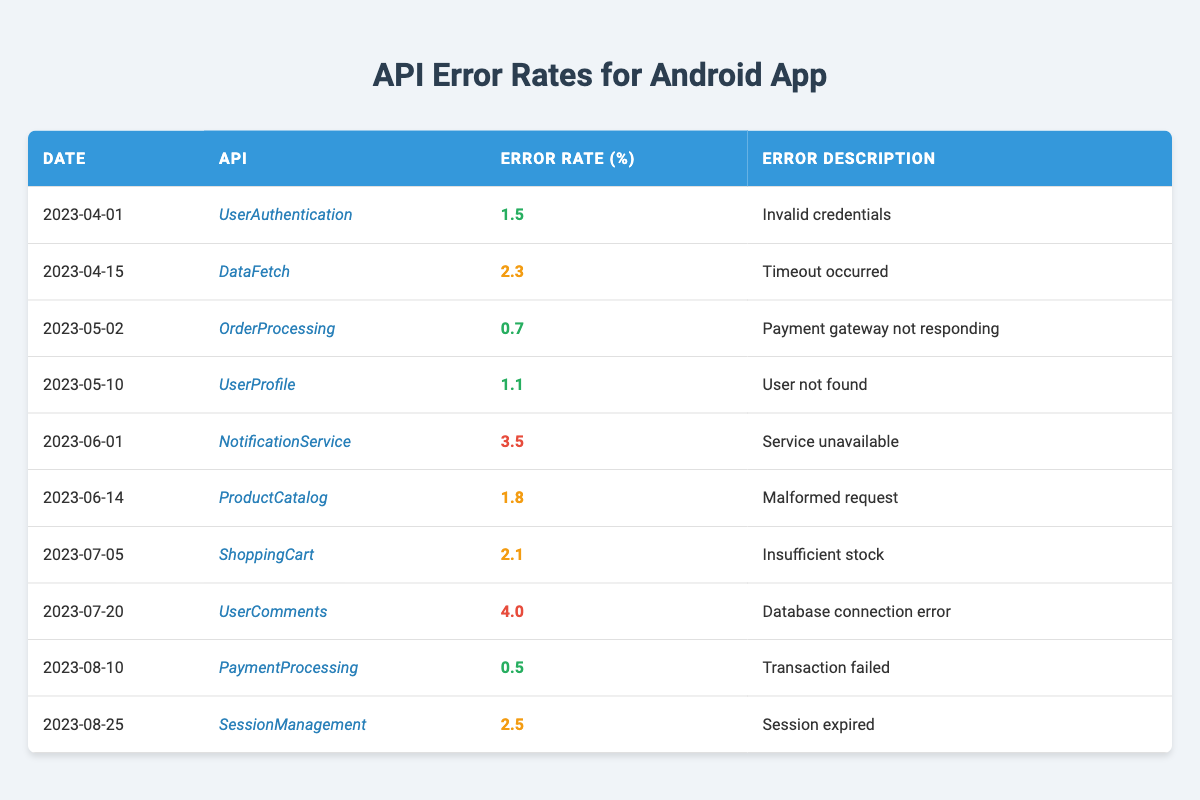What is the highest error rate recorded for an API call? The highest error rate in the table is 4.0, which corresponds to the UserComments API on 2023-07-20.
Answer: 4.0 On which date did the NotificationService API experience its error rate? The NotificationService API's error rate of 3.5 is recorded on 2023-06-01.
Answer: 2023-06-01 How many API calls had an error rate greater than 2.0? The API calls with error rates greater than 2.0 are DataFetch (2.3), NotificationService (3.5), UserComments (4.0), and SessionManagement (2.5), totaling 4 calls.
Answer: 4 Which API had the lowest error rate, and what was the percentage? The API with the lowest error rate is PaymentProcessing, with an error rate of 0.5 recorded on 2023-08-10.
Answer: PaymentProcessing, 0.5 What is the average error rate for all API calls in the last six months? The error rates are 1.5, 2.3, 0.7, 1.1, 3.5, 1.8, 2.1, 4.0, 0.5, and 2.5. The sum of these rates is 20.5, and dividing by the number of calls (10) gives an average of 2.05.
Answer: 2.05 Did the OrderProcessing API ever exceed an error rate of 1.0? The error rate for OrderProcessing was 0.7 on 2023-05-02, which does not exceed 1.0. Therefore, the answer is no.
Answer: No Over which months did the error rates trend upward? By examining the data, there are peaks in June and July, particularly with the notification and user comments APIs. Thus, there’s an upward trend primarily between June and July.
Answer: June to July What was the error description for the highest error rate API? The error description for UserComments, which has the highest error rate of 4.0, is "Database connection error."
Answer: Database connection error 